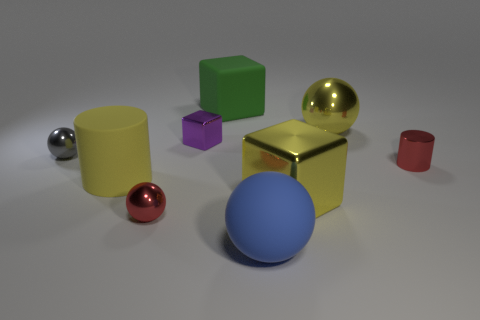Are there any big blue matte balls on the right side of the yellow metallic ball?
Your response must be concise. No. Are there any yellow rubber objects that have the same shape as the green rubber thing?
Your answer should be compact. No. What is the shape of the gray thing that is the same size as the purple cube?
Your answer should be compact. Sphere. What number of things are either red metal things that are on the right side of the tiny purple object or tiny red metal cylinders?
Your response must be concise. 1. Do the metallic cylinder and the small block have the same color?
Offer a very short reply. No. There is a shiny block that is to the left of the green matte cube; how big is it?
Your answer should be very brief. Small. Are there any matte spheres of the same size as the blue thing?
Your answer should be very brief. No. There is a metal sphere that is behind the purple object; does it have the same size as the matte cylinder?
Keep it short and to the point. Yes. What is the size of the blue matte sphere?
Keep it short and to the point. Large. There is a small object that is left of the rubber object on the left side of the small red thing in front of the yellow rubber thing; what is its color?
Give a very brief answer. Gray. 